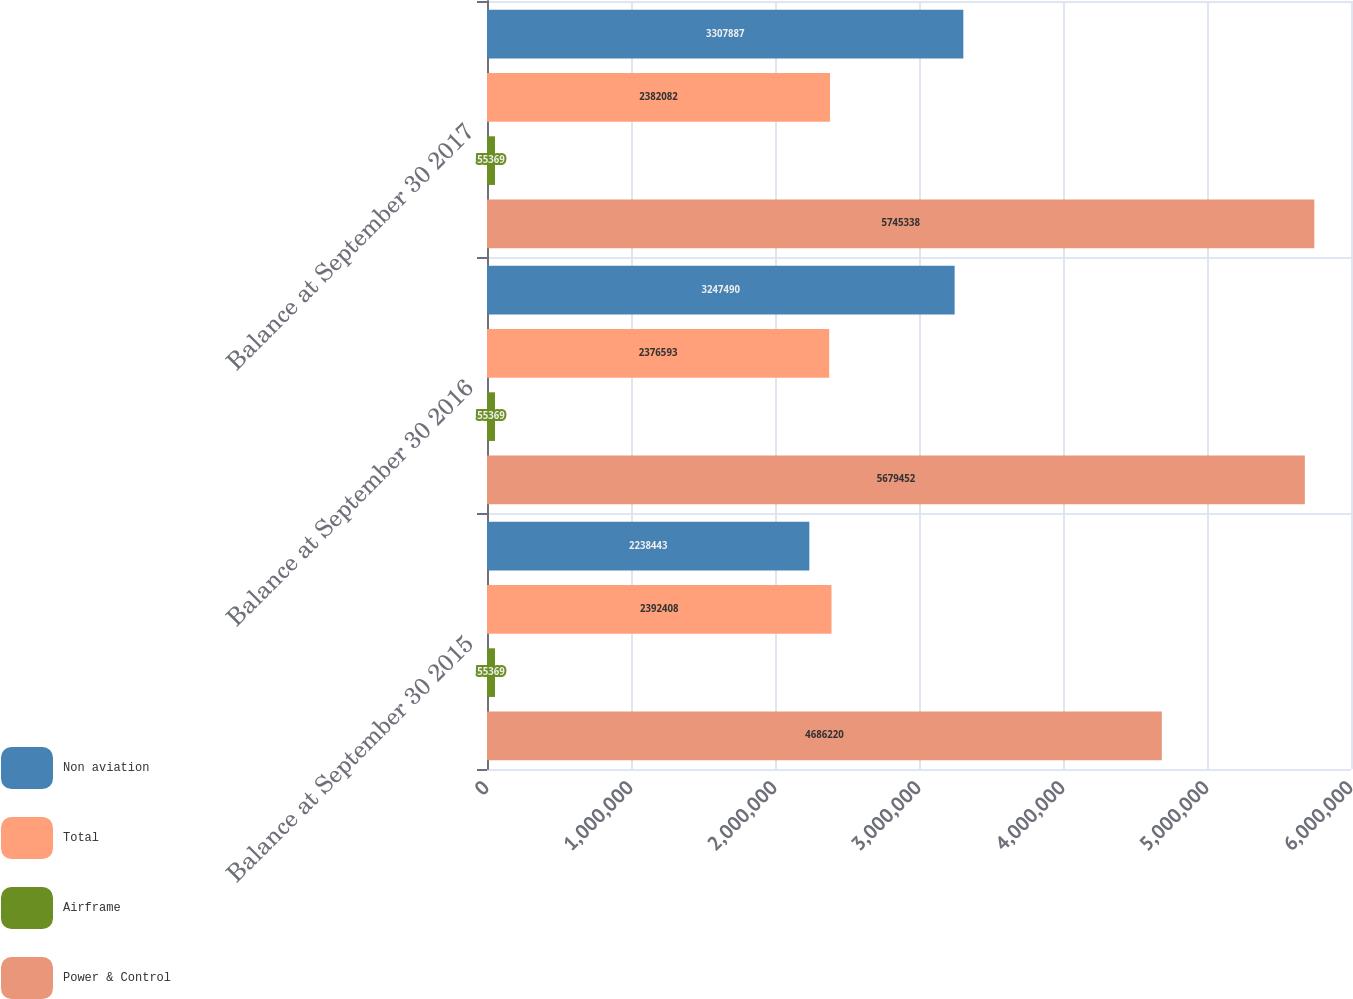Convert chart. <chart><loc_0><loc_0><loc_500><loc_500><stacked_bar_chart><ecel><fcel>Balance at September 30 2015<fcel>Balance at September 30 2016<fcel>Balance at September 30 2017<nl><fcel>Non aviation<fcel>2.23844e+06<fcel>3.24749e+06<fcel>3.30789e+06<nl><fcel>Total<fcel>2.39241e+06<fcel>2.37659e+06<fcel>2.38208e+06<nl><fcel>Airframe<fcel>55369<fcel>55369<fcel>55369<nl><fcel>Power & Control<fcel>4.68622e+06<fcel>5.67945e+06<fcel>5.74534e+06<nl></chart> 